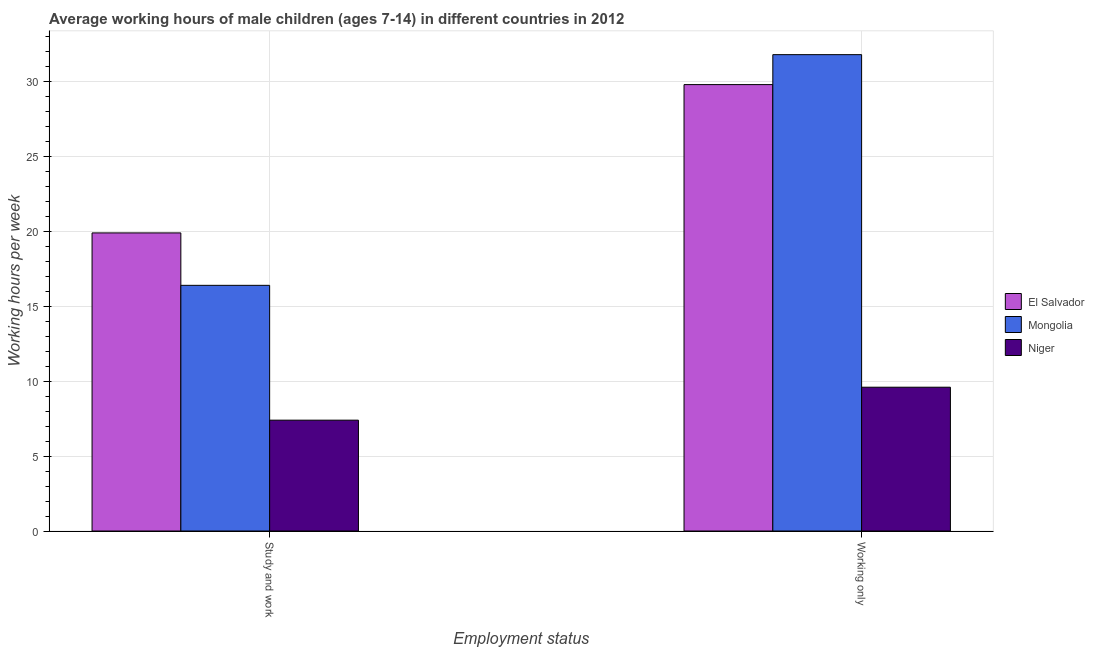How many different coloured bars are there?
Your answer should be compact. 3. Are the number of bars per tick equal to the number of legend labels?
Your answer should be very brief. Yes. Are the number of bars on each tick of the X-axis equal?
Make the answer very short. Yes. How many bars are there on the 2nd tick from the left?
Provide a short and direct response. 3. What is the label of the 2nd group of bars from the left?
Make the answer very short. Working only. What is the average working hour of children involved in only work in Mongolia?
Your answer should be compact. 31.8. Across all countries, what is the minimum average working hour of children involved in only work?
Offer a terse response. 9.6. In which country was the average working hour of children involved in only work maximum?
Your response must be concise. Mongolia. In which country was the average working hour of children involved in only work minimum?
Ensure brevity in your answer.  Niger. What is the total average working hour of children involved in only work in the graph?
Your response must be concise. 71.2. What is the difference between the average working hour of children involved in only work in Niger and that in Mongolia?
Provide a succinct answer. -22.2. What is the difference between the average working hour of children involved in only work in Mongolia and the average working hour of children involved in study and work in El Salvador?
Your answer should be very brief. 11.9. What is the average average working hour of children involved in only work per country?
Make the answer very short. 23.73. What is the difference between the average working hour of children involved in only work and average working hour of children involved in study and work in Niger?
Make the answer very short. 2.2. What is the ratio of the average working hour of children involved in study and work in Niger to that in Mongolia?
Offer a very short reply. 0.45. Is the average working hour of children involved in only work in Mongolia less than that in El Salvador?
Offer a terse response. No. In how many countries, is the average working hour of children involved in study and work greater than the average average working hour of children involved in study and work taken over all countries?
Make the answer very short. 2. What does the 3rd bar from the left in Study and work represents?
Offer a very short reply. Niger. What does the 1st bar from the right in Study and work represents?
Provide a succinct answer. Niger. How many bars are there?
Your answer should be compact. 6. Are all the bars in the graph horizontal?
Ensure brevity in your answer.  No. Are the values on the major ticks of Y-axis written in scientific E-notation?
Your response must be concise. No. How many legend labels are there?
Your response must be concise. 3. What is the title of the graph?
Offer a very short reply. Average working hours of male children (ages 7-14) in different countries in 2012. What is the label or title of the X-axis?
Give a very brief answer. Employment status. What is the label or title of the Y-axis?
Make the answer very short. Working hours per week. What is the Working hours per week in El Salvador in Working only?
Your response must be concise. 29.8. What is the Working hours per week in Mongolia in Working only?
Make the answer very short. 31.8. What is the Working hours per week in Niger in Working only?
Keep it short and to the point. 9.6. Across all Employment status, what is the maximum Working hours per week of El Salvador?
Keep it short and to the point. 29.8. Across all Employment status, what is the maximum Working hours per week of Mongolia?
Offer a terse response. 31.8. Across all Employment status, what is the minimum Working hours per week of El Salvador?
Offer a terse response. 19.9. What is the total Working hours per week of El Salvador in the graph?
Make the answer very short. 49.7. What is the total Working hours per week of Mongolia in the graph?
Your response must be concise. 48.2. What is the total Working hours per week in Niger in the graph?
Offer a terse response. 17. What is the difference between the Working hours per week in Mongolia in Study and work and that in Working only?
Your answer should be compact. -15.4. What is the difference between the Working hours per week in El Salvador in Study and work and the Working hours per week in Mongolia in Working only?
Give a very brief answer. -11.9. What is the difference between the Working hours per week of Mongolia in Study and work and the Working hours per week of Niger in Working only?
Provide a short and direct response. 6.8. What is the average Working hours per week of El Salvador per Employment status?
Ensure brevity in your answer.  24.85. What is the average Working hours per week of Mongolia per Employment status?
Keep it short and to the point. 24.1. What is the average Working hours per week in Niger per Employment status?
Ensure brevity in your answer.  8.5. What is the difference between the Working hours per week of Mongolia and Working hours per week of Niger in Study and work?
Keep it short and to the point. 9. What is the difference between the Working hours per week in El Salvador and Working hours per week in Mongolia in Working only?
Make the answer very short. -2. What is the difference between the Working hours per week in El Salvador and Working hours per week in Niger in Working only?
Provide a short and direct response. 20.2. What is the ratio of the Working hours per week in El Salvador in Study and work to that in Working only?
Offer a terse response. 0.67. What is the ratio of the Working hours per week of Mongolia in Study and work to that in Working only?
Ensure brevity in your answer.  0.52. What is the ratio of the Working hours per week of Niger in Study and work to that in Working only?
Offer a very short reply. 0.77. What is the difference between the highest and the second highest Working hours per week of Mongolia?
Your answer should be compact. 15.4. What is the difference between the highest and the second highest Working hours per week in Niger?
Provide a short and direct response. 2.2. What is the difference between the highest and the lowest Working hours per week in Mongolia?
Your answer should be compact. 15.4. What is the difference between the highest and the lowest Working hours per week in Niger?
Your answer should be compact. 2.2. 